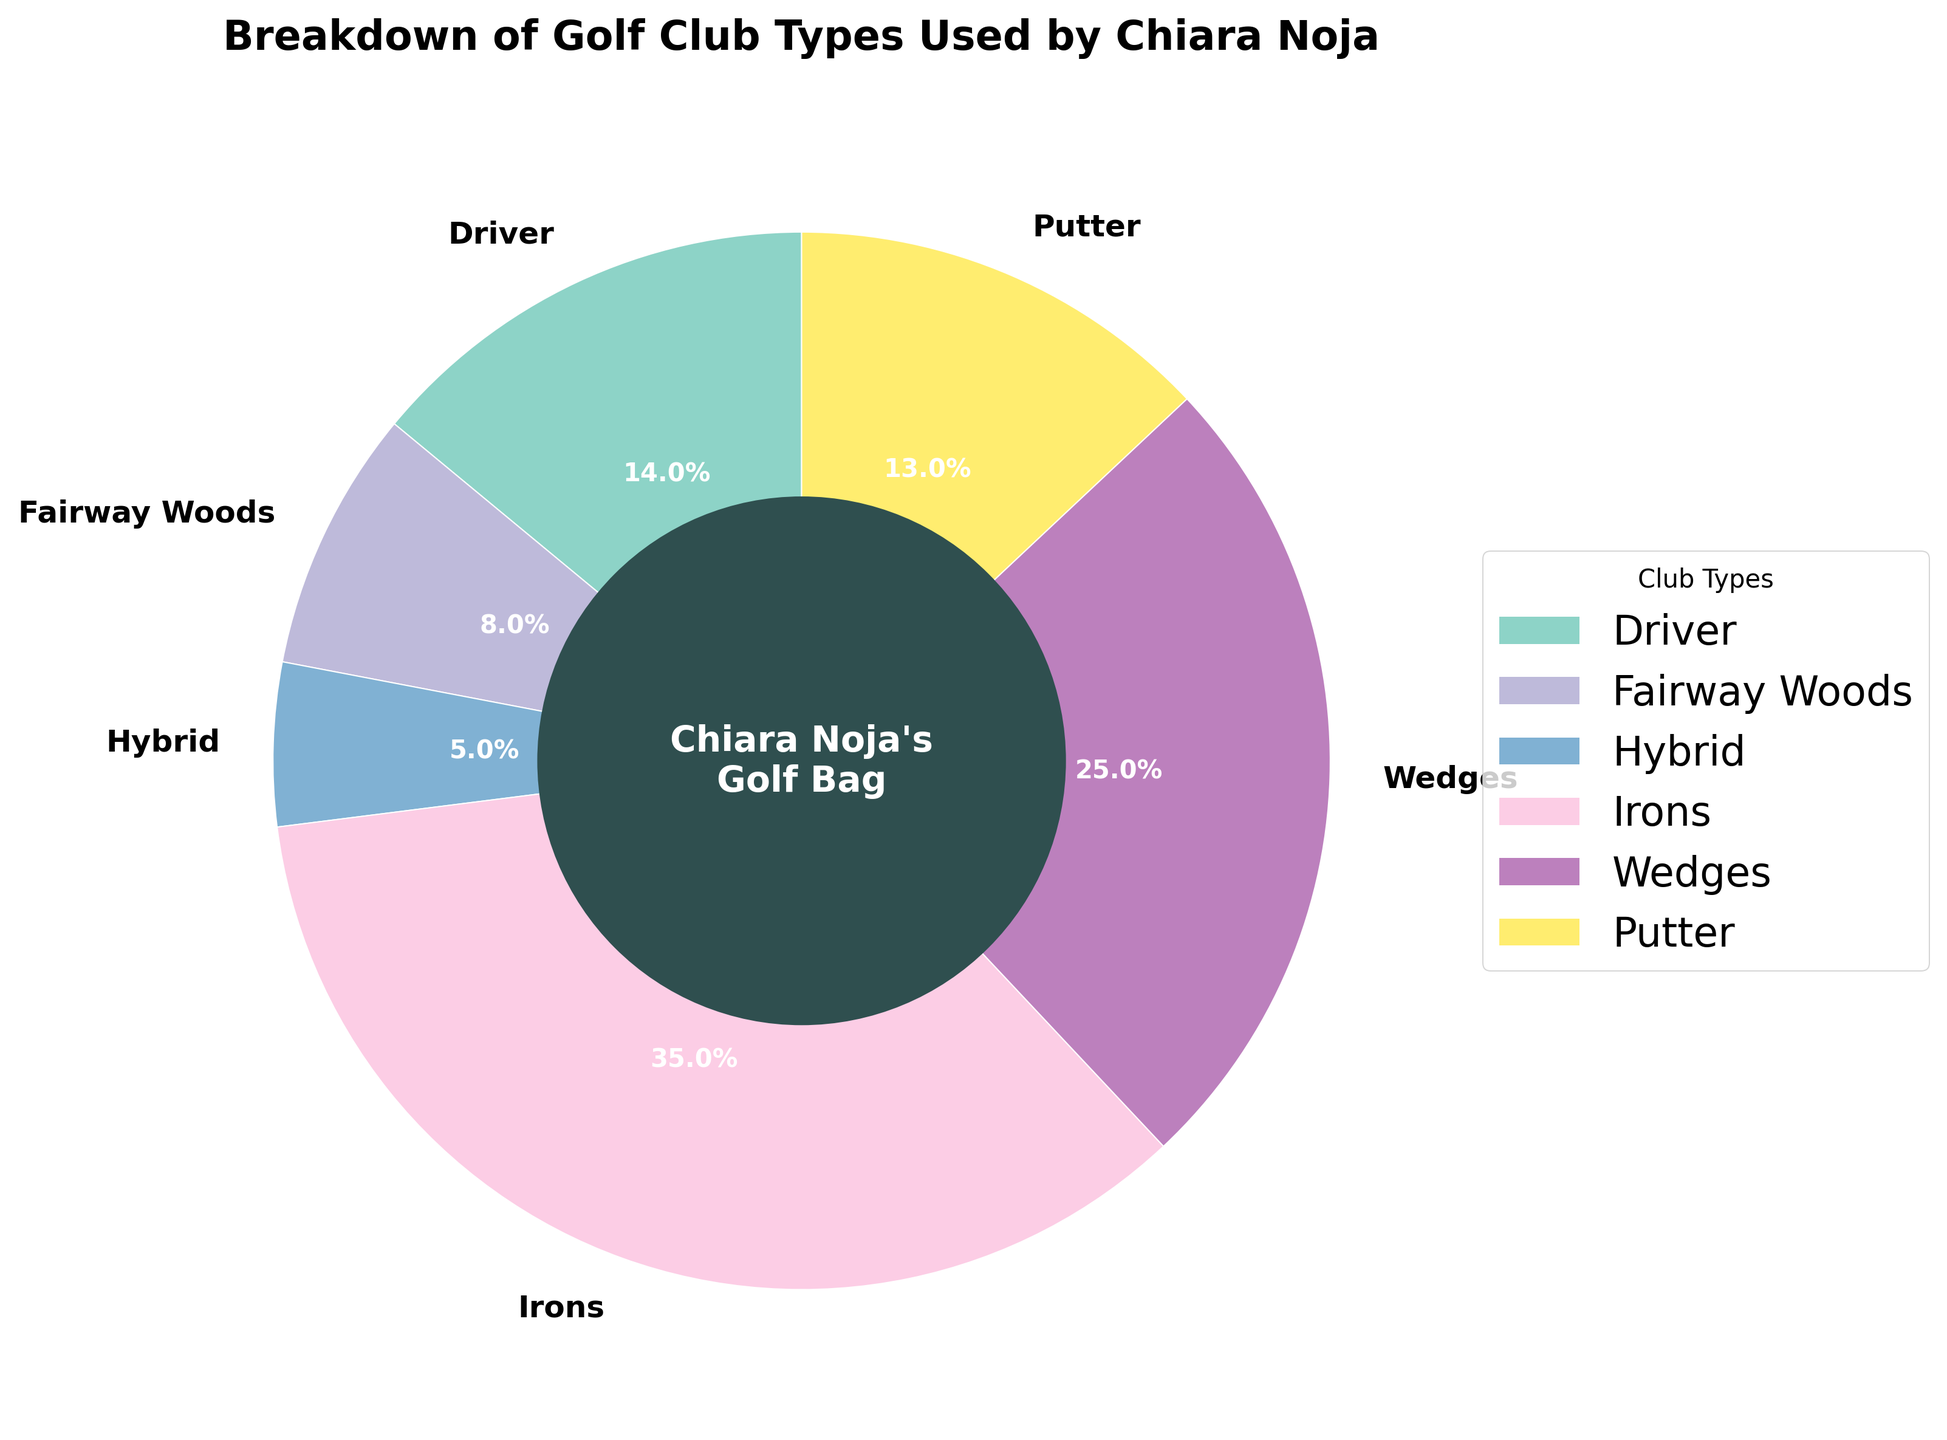Which golf club type does Chiara Noja use the most? The wedge with the largest percentage represents the club type Chiara Noja uses the most. According to the pie chart, the largest segment is "Irons" at 35%.
Answer: Irons Which golf club type does Chiara Noja use the least? The wedge with the smallest percentage represents the club type Chiara Noja uses the least. The smallest segment on the chart is "Hybrid" at 5%.
Answer: Hybrid Is the percentage of the driver usage greater or less than the putter usage? Comparing the segments for driver and putter, the driver segment is labeled 14% and the putter segment is labeled 13%. Therefore, the driver usage is greater.
Answer: Greater What is the combined percentage of fairway woods and hybrid clubs used by Chiara Noja? To find the combined percentage, we sum the percentages assigned to fairway woods and hybrid clubs: 8% + 5% = 13%.
Answer: 13% What is the percentage difference between the wedges and driver usage? To find the difference, subtract the driver's percentage from the wedges' percentage: 25% - 14% = 11%.
Answer: 11% Which sections of the pie chart are bigger in size than the putter section? Segments larger than the putter (13%) are: Driver (14%), Irons (35%), and Wedges (25%).
Answer: Driver, Irons, Wedges How do the usage percentages of irons and wedges compare? Comparing the wedges for irons and wedges, irons at 35% and wedges at 25%, irons usage is higher by 10 percentage points.
Answer: Irons are 10% higher What is the combined percentage for all the categories except irons? To find this, subtract the percentage for irons from 100%: 100% - 35% = 65%.
Answer: 65% What section is directly opposite the hybrid section in the pie chart starting from the top? Identifying the position of sections, hybrid (5%) is at the bottom. Directly opposite would be at the top. The top section is the Irons at 35%.
Answer: Irons How many club types have a usage percentage above 10%? Checking each segment: Driver (14%), Irons (35%), Wedges (25%), and Putter (13%) are above 10%. That's 4 club types.
Answer: 4 